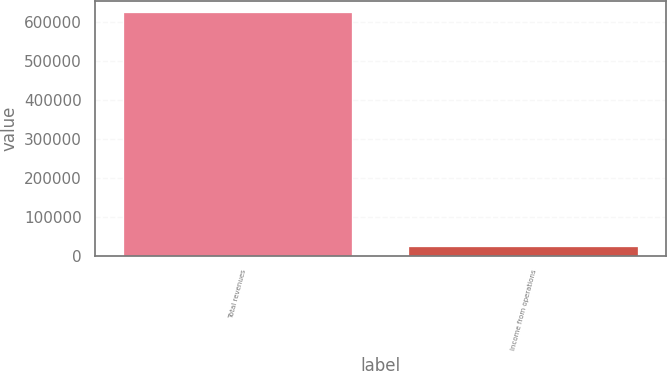Convert chart to OTSL. <chart><loc_0><loc_0><loc_500><loc_500><bar_chart><fcel>Total revenues<fcel>Income from operations<nl><fcel>623245<fcel>24131<nl></chart> 